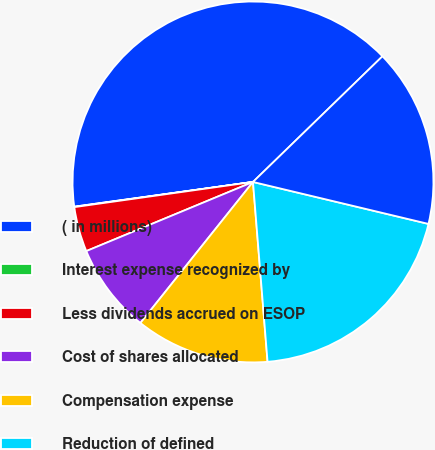<chart> <loc_0><loc_0><loc_500><loc_500><pie_chart><fcel>( in millions)<fcel>Interest expense recognized by<fcel>Less dividends accrued on ESOP<fcel>Cost of shares allocated<fcel>Compensation expense<fcel>Reduction of defined<fcel>ESOP benefit<nl><fcel>39.93%<fcel>0.04%<fcel>4.03%<fcel>8.02%<fcel>12.01%<fcel>19.98%<fcel>16.0%<nl></chart> 